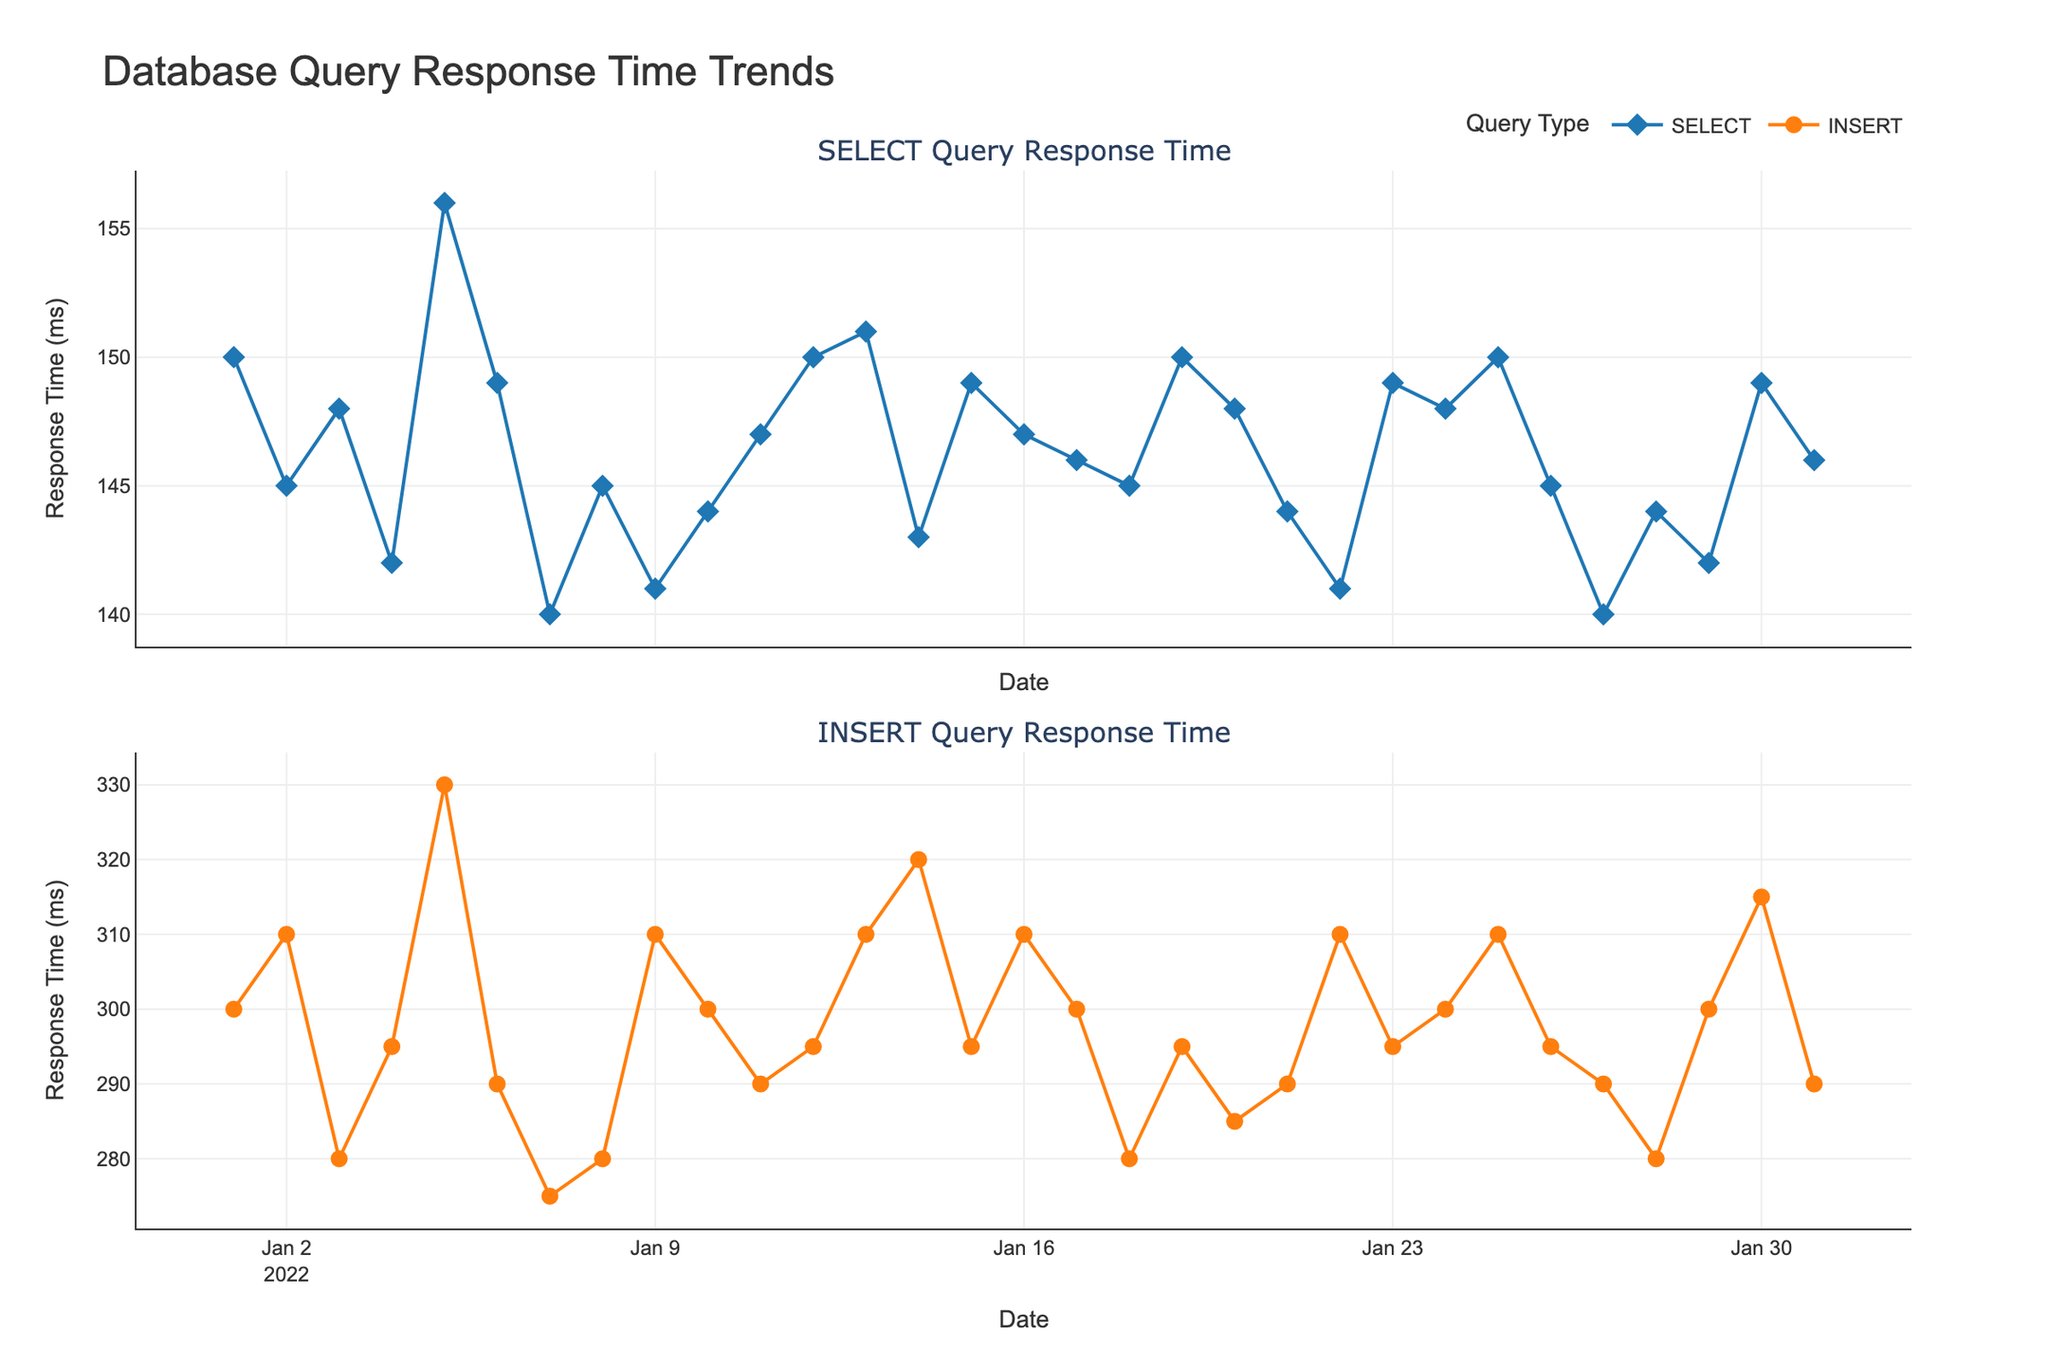What is the title of the figure? The title is usually prominently displayed at the top of the chart. By looking at the top, we can see the words that form the title.
Answer: Database Query Response Time Trends What do the y-axis titles represent in the figure? Each subplot typically has a y-axis title indicating what is being measured. The top subplot represents "SELECT Query Response Time" and the bottom subplot represents "INSERT Query Response Time". Thus, both refer to response times in milliseconds.
Answer: Response Time (ms) How many subplots are there in the figure? By visually inspecting the figure, we can see that it's divided into two horizontal sections, each representing a different type of query response time.
Answer: 2 Which query type has the higher response time on January 10, 2022? We compare the heights of the points for the SELECT and INSERT queries on January 10, 2022 by looking at the respective subplots for that date. The INSERT query has a response time of 300 ms, while the SELECT query has a response time of 144 ms.
Answer: INSERT On what date was the response time for SELECT queries the lowest, and what was the response time? By tracing the SELECT response times, we find the lowest point and check the corresponding date label on the x-axis. On January 7, 2022, the SELECT response time was at its lowest, with 140 ms.
Answer: January 7, 2022, and 140 ms What is the average response time for INSERT queries from January 1 to January 31, 2022? We calculate the average by adding the response times for INSERT queries and then dividing by the number of days (31). (300 + 310 + 280 + 295 + 330 + 290 + 275 + 280 + 310 + 300 + 290 + 295 + 310 + 320 + 295 + 310 + 300 + 280 + 295 + 285 + 290 + 310 + 295 + 300 + 310 + 295 + 290 + 280 + 300 + 315 + 290) / 31 = 299.83
Answer: 299.83 ms Did the SELECT query response time ever exceed 150 ms? If so, on what dates? We look for any data points in the SELECT subplot where the y-values exceed 150 ms. This happened on January 1, 2022, January 5, 2022, January 12, 2022, January 15, 2022, January 19, 2022, January 25, 2022, January 30, 2022.
Answer: Yes, on January 1, 5, 12, 15, 19, 25, 30, 2022 What is the difference in response time between INSERT and SELECT queries on January 30, 2022? We find the response times for both queries on January 30, 2022 from the subplots. The INSERT response time is 315 ms and the SELECT response time is 149 ms. The difference is 315 - 149 = 166 ms.
Answer: 166 ms Which day had the highest response time for INSERT queries, and what was the response time? By tracing the INSERT response times, we find the highest point and check the corresponding date label on the x-axis. On January 30, 2022, the INSERT response time was the highest at 315 ms.
Answer: January 30, 2022, and 315 ms 